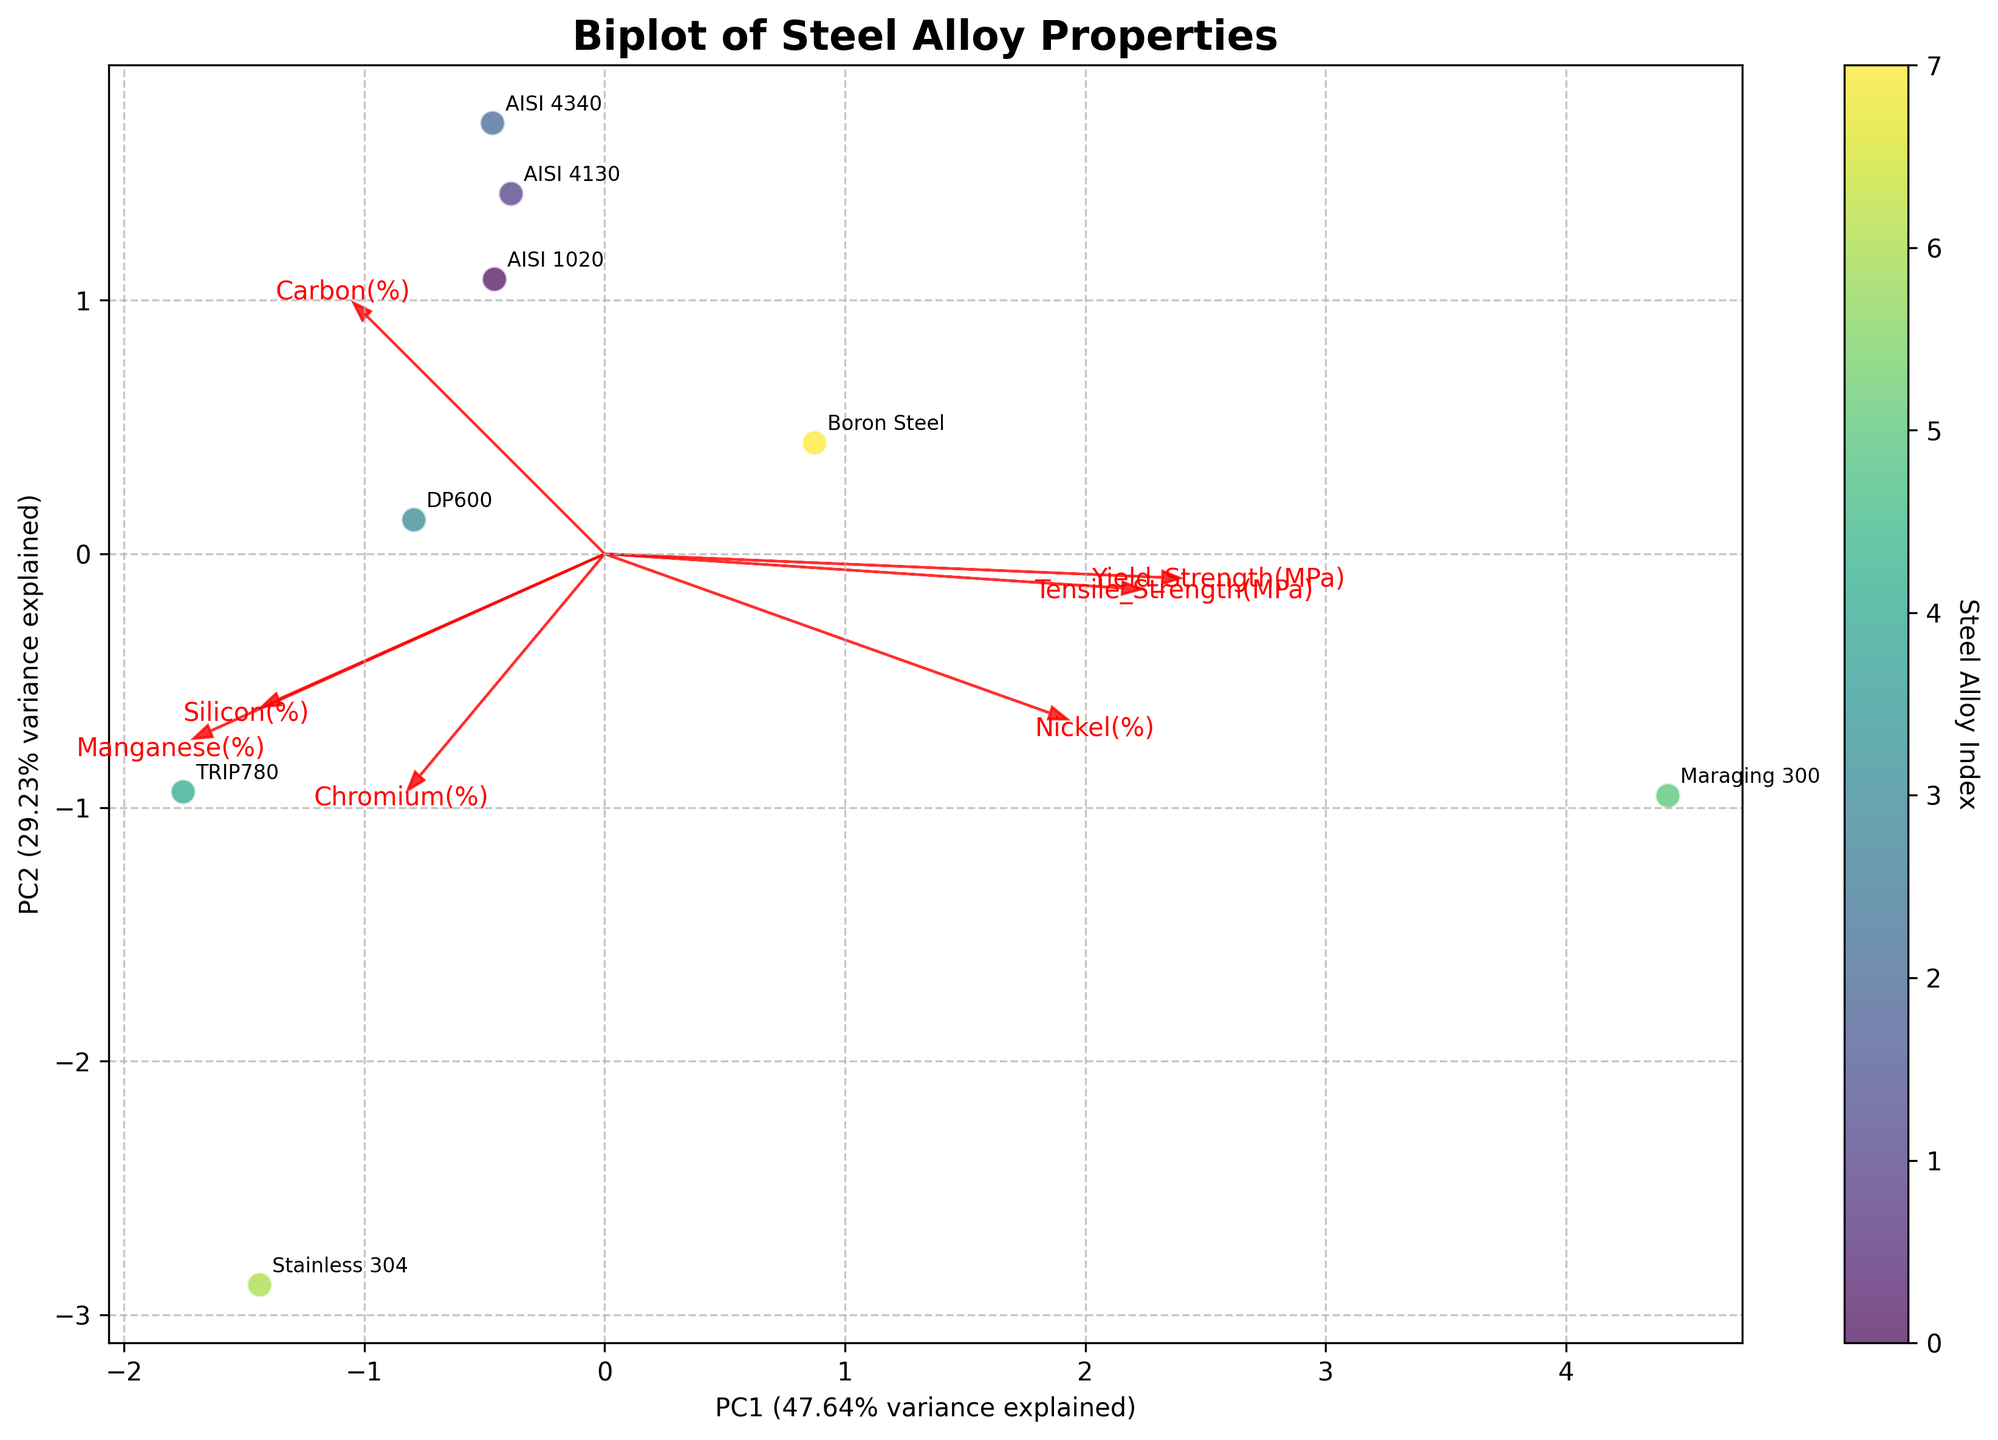How many steel alloys are represented in the biplot? The plot has annotations for each steel alloy and their unique positions. Count the number of different annotations.
Answer: 8 Which steel alloy has the highest value on the PC1 axis? Locate the steel alloy label that is furthest to the right along the PC1 axis.
Answer: Maraging 300 What percentage of the total variance is explained by the first principal component (PC1)? Look at the label for the PC1 axis; it includes the percentage of variance explained by PC1.
Answer: 41% Which steel alloy is closest to the origin in the biplot? Find the label that is positioned nearest to the point (0,0) on the plot.
Answer: AISI 1020 Do alloys with higher carbon content generally have higher tensile strengths? Inspect the plot to see if steel alloys with higher values along the direction of the “Carbon (%)” arrow also have higher values along the direction of the “Tensile_Strength (MPa)” arrow. In this plot, check the positioning of AISI 1020, AISI 4130, and AISI 4340.
Answer: Yes Which feature vector is most aligned with the PC2 axis? Determine which red arrow is oriented most closely along the vertical direction (PC2 axis).
Answer: Yield_Strength (MPa) Is Manganese (%) more strongly correlated with PC1 or PC2? Look at the orientation of the "Manganese (%)" arrow and see if it aligns more closely with the horizontal (PC1) or vertical (PC2) axis.
Answer: PC2 How much variance is explained by the second principal component (PC2)? Look at the label for the PC2 axis; it includes the percentage of variance explained by PC2.
Answer: 28% Which steel alloy has the lowest yield strength according to the biplot? Examine the annotations and positions of the steel alloys relative to the "Yield_Strength (MPa)" arrow to determine which is lowest in value.
Answer: Stainless 304 Is there any steel alloy with a significant amount of Nickel (%) that is also very strong in tensile strength? Identify steel alloys that lie far along both the "Nickel (%)" and "Tensile_Strength (MPa)" arrows.
Answer: Maraging 300 How do the properties of DP600 compare to those of TRIP780 in terms of tensile and yield strength? Locate the positions of DP600 and TRIP780 in relation to the "Tensile_Strength (MPa)" and "Yield_Strength (MPa)" arrows.
Answer: TRIP780 has higher tensile and yield strength than DP600 